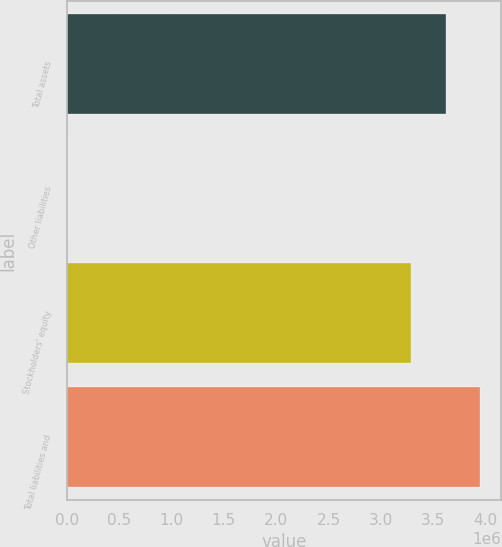Convert chart. <chart><loc_0><loc_0><loc_500><loc_500><bar_chart><fcel>Total assets<fcel>Other liabilities<fcel>Stockholders' equity<fcel>Total liabilities and<nl><fcel>3.619e+06<fcel>12<fcel>3.28944e+06<fcel>3.94856e+06<nl></chart> 